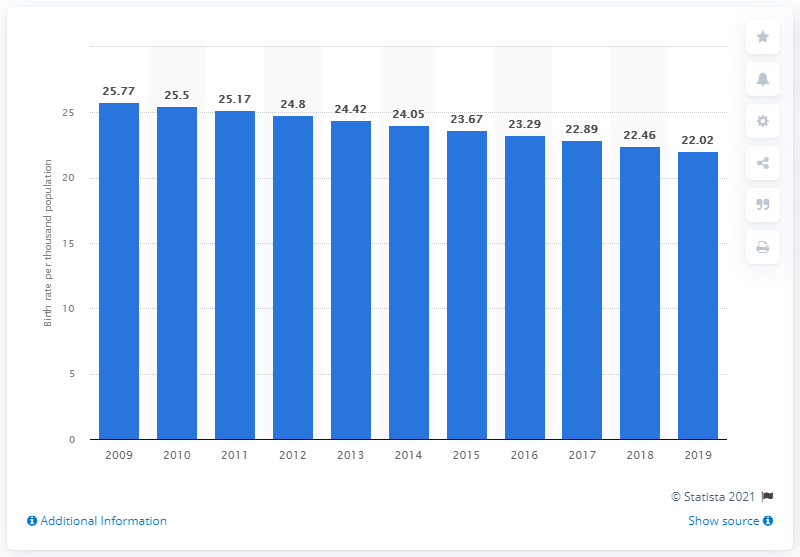Give some essential details in this illustration. According to data from 2019, the crude birth rate in Cambodia was 22.02. 